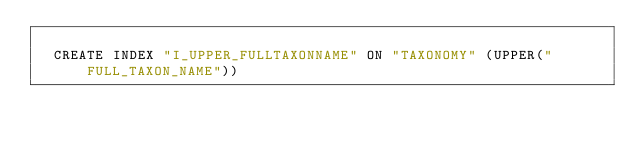<code> <loc_0><loc_0><loc_500><loc_500><_SQL_>
  CREATE INDEX "I_UPPER_FULLTAXONNAME" ON "TAXONOMY" (UPPER("FULL_TAXON_NAME")) 
  </code> 